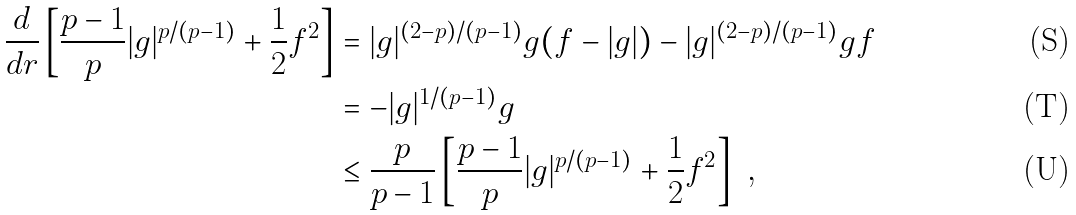<formula> <loc_0><loc_0><loc_500><loc_500>\frac { d } { d r } \left [ \frac { p - 1 } { p } | g | ^ { p / ( p - 1 ) } + \frac { 1 } { 2 } f ^ { 2 } \right ] & = | g | ^ { ( 2 - p ) / ( p - 1 ) } g ( f - | g | ) - | g | ^ { ( 2 - p ) / ( p - 1 ) } g f \\ & = - | g | ^ { 1 / ( p - 1 ) } g \\ & \leq \frac { p } { p - 1 } \left [ \frac { p - 1 } { p } | g | ^ { p / ( p - 1 ) } + \frac { 1 } { 2 } f ^ { 2 } \right ] \ ,</formula> 